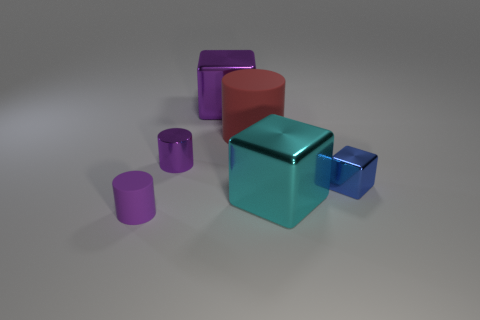What material is the purple object that is both behind the cyan metal cube and in front of the big purple shiny object? metal 